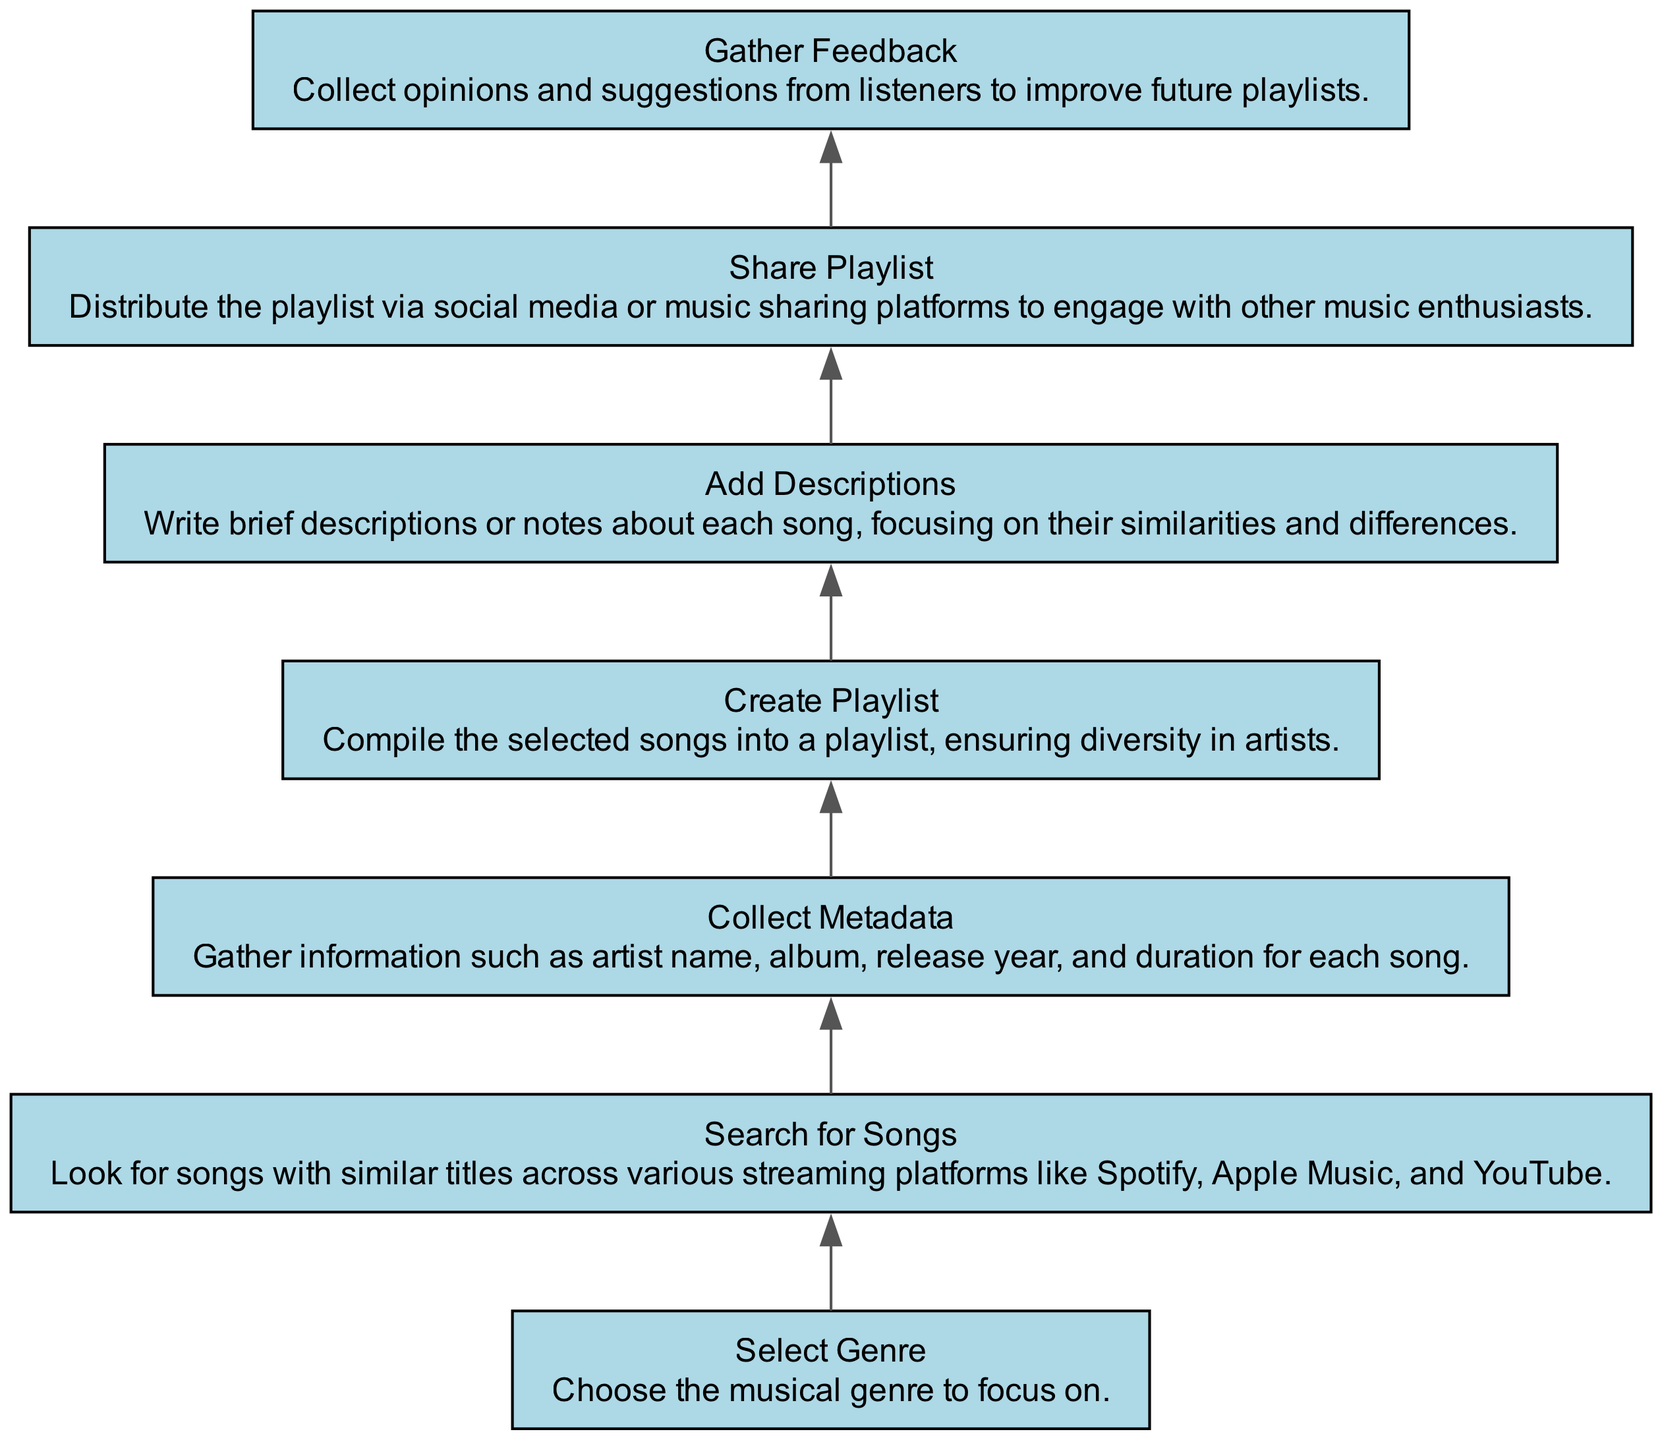What is the first step in the playlist creation process? The first step is to "Select Genre," which involves choosing the musical genre to focus on. This information is located at the top of the flow chart.
Answer: Select Genre How many nodes are there in the diagram? The diagram contains seven nodes, each representing different steps in the playlist creation process. This can be counted visually in the diagram.
Answer: Seven Which step comes after "Search for Songs"? The step that comes after "Search for Songs" is "Collect Metadata." This is indicated by the directed flow connecting the two nodes.
Answer: Collect Metadata What is the last step in the process? The last step in the process is "Gather Feedback," which is positioned at the bottom of the flow chart, following all other steps.
Answer: Gather Feedback How many connections (edges) are in the diagram? There are six connections (edges) in the diagram, linking the seven nodes together in a sequential manner. This can be counted visually from the arrows in the flow chart.
Answer: Six What are the two nodes that directly connect to "Create Playlist"? The two nodes that connect directly to "Create Playlist" are "Collect Metadata" which flows into it, and "Add Descriptions," which flows out of it. This relationship indicates the plural steps surrounding this node in the flow chart.
Answer: Collect Metadata and Add Descriptions What action follows "Add Descriptions"? The action that follows "Add Descriptions" is "Share Playlist," which illustrates the next step in the process after describing the songs. This is inferred from the directional flow between the two nodes.
Answer: Share Playlist Which element is focused on musician genre? The element focusing on musician genre is "Select Genre," as it involves choosing the musical genre to guide the subsequent steps in the creation of a playlist.
Answer: Select Genre What is the main purpose of the flow chart? The main purpose of the flow chart is to outline the steps involved in creating a playlist for songs with similar titles, leading from selection to sharing. Each node represents a key phase in this process.
Answer: Outline playlist creation steps 